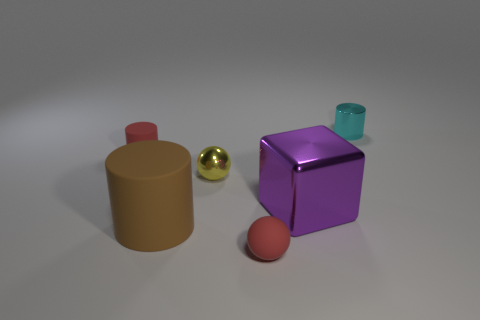Is there a clear hierarchy in terms of size among the objects? Yes, the purple cube is the largest object, followed by the brown cylinder; the red sphere and golden sphere are smaller, and the smallest object is the blue glass. What can you tell me about the lighting in the scene? The lighting in the scene appears to be soft and diffuse, coming from above. It creates soft shadows directly underneath the objects, suggesting an indoor environment with a single overhead light source. 